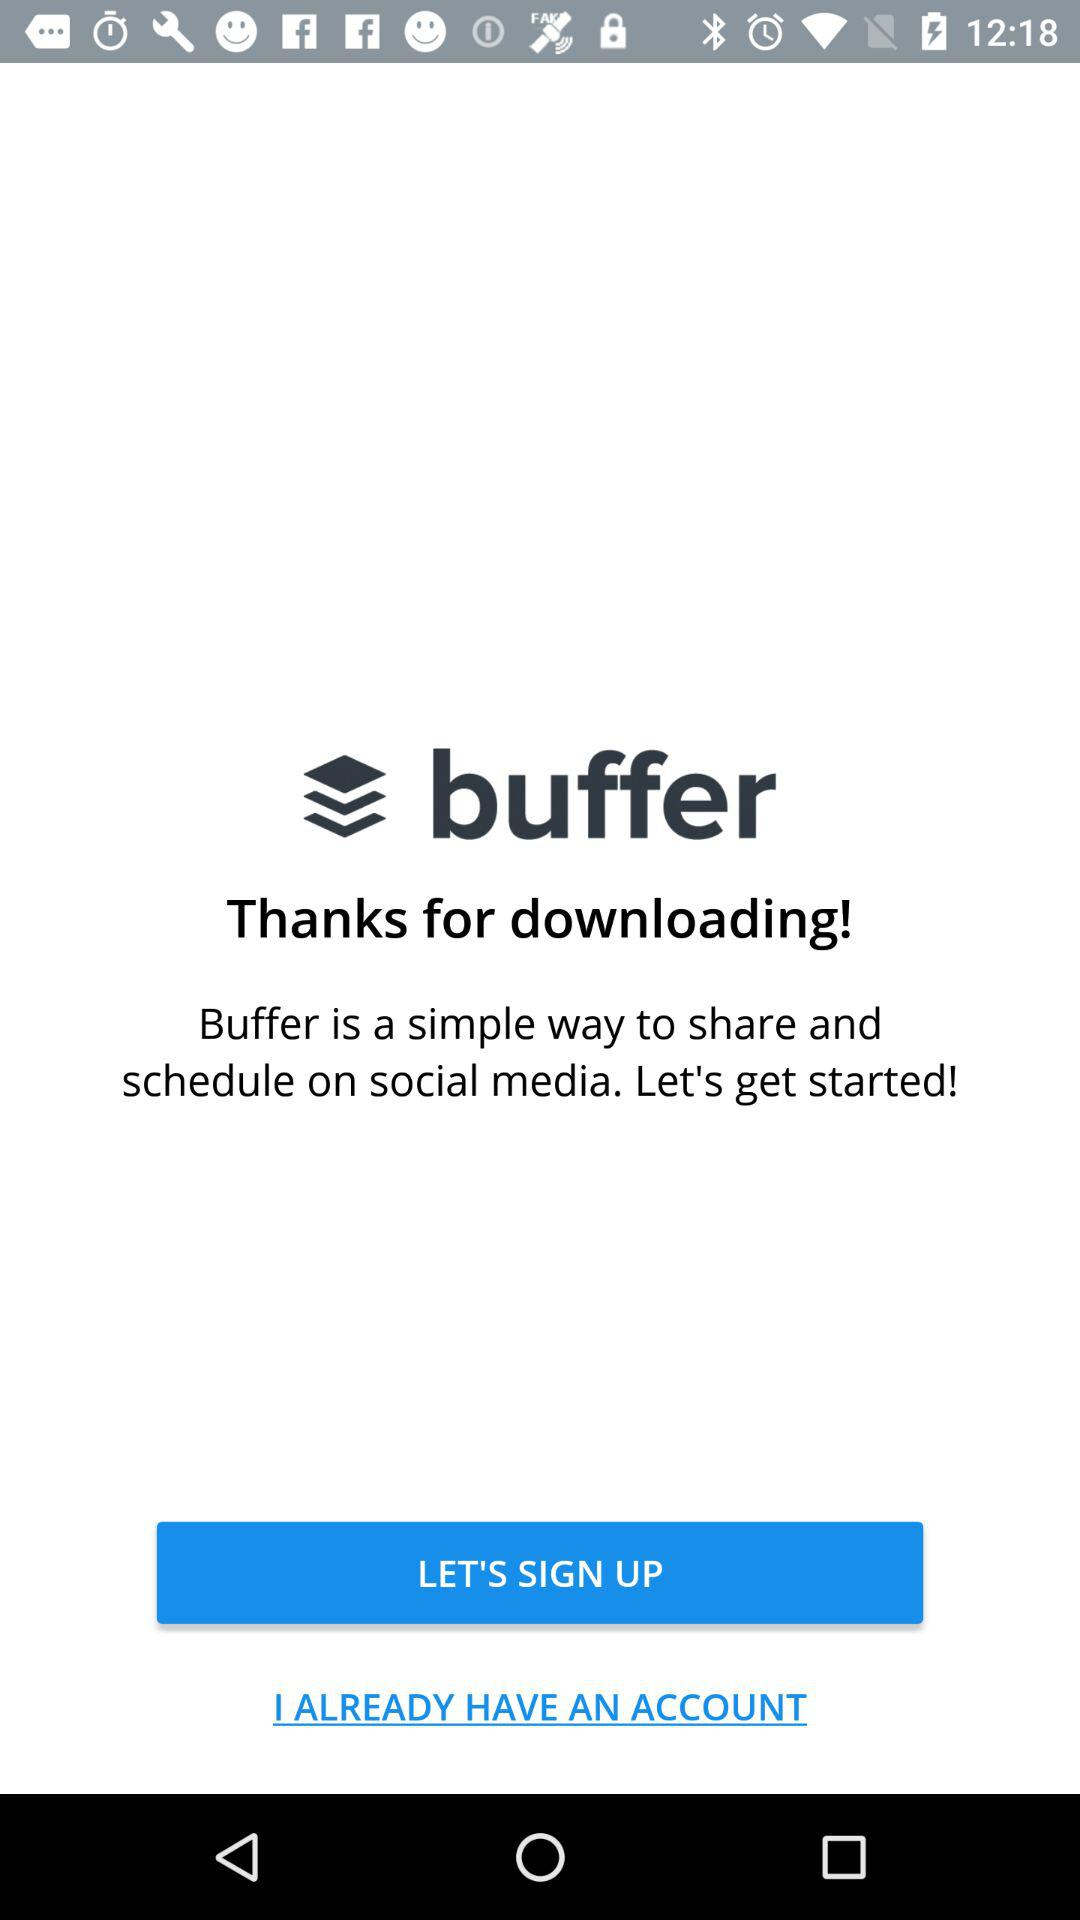What is the application name? The application name is "buffer". 